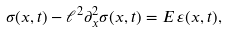<formula> <loc_0><loc_0><loc_500><loc_500>\sigma ( x , t ) - \ell ^ { 2 } \partial _ { x } ^ { 2 } \sigma ( x , t ) = E \, \varepsilon ( x , t ) ,</formula> 